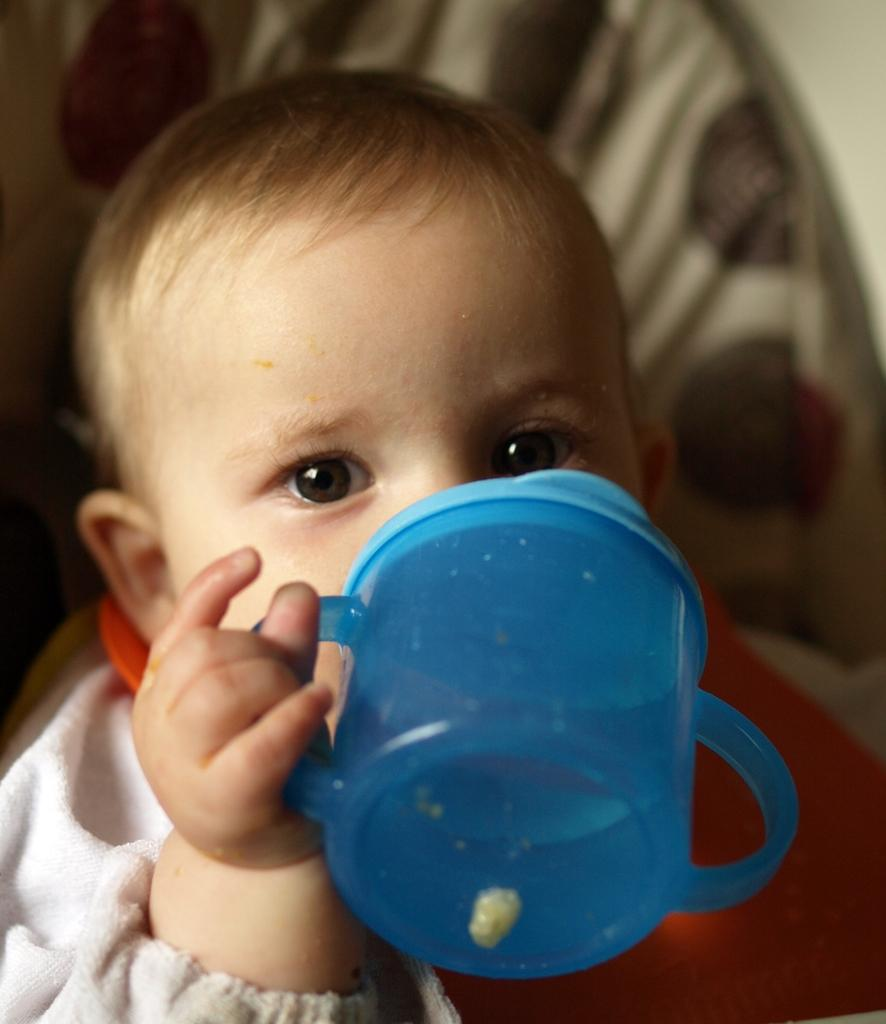What is the main subject of the image? The main subject of the image is a kid. What is the kid holding in his hand? The kid is holding a zipper in his hand. What type of plants can be seen growing in the lunchroom in the image? There is no lunchroom or plants present in the image; it features a kid holding a zipper. 